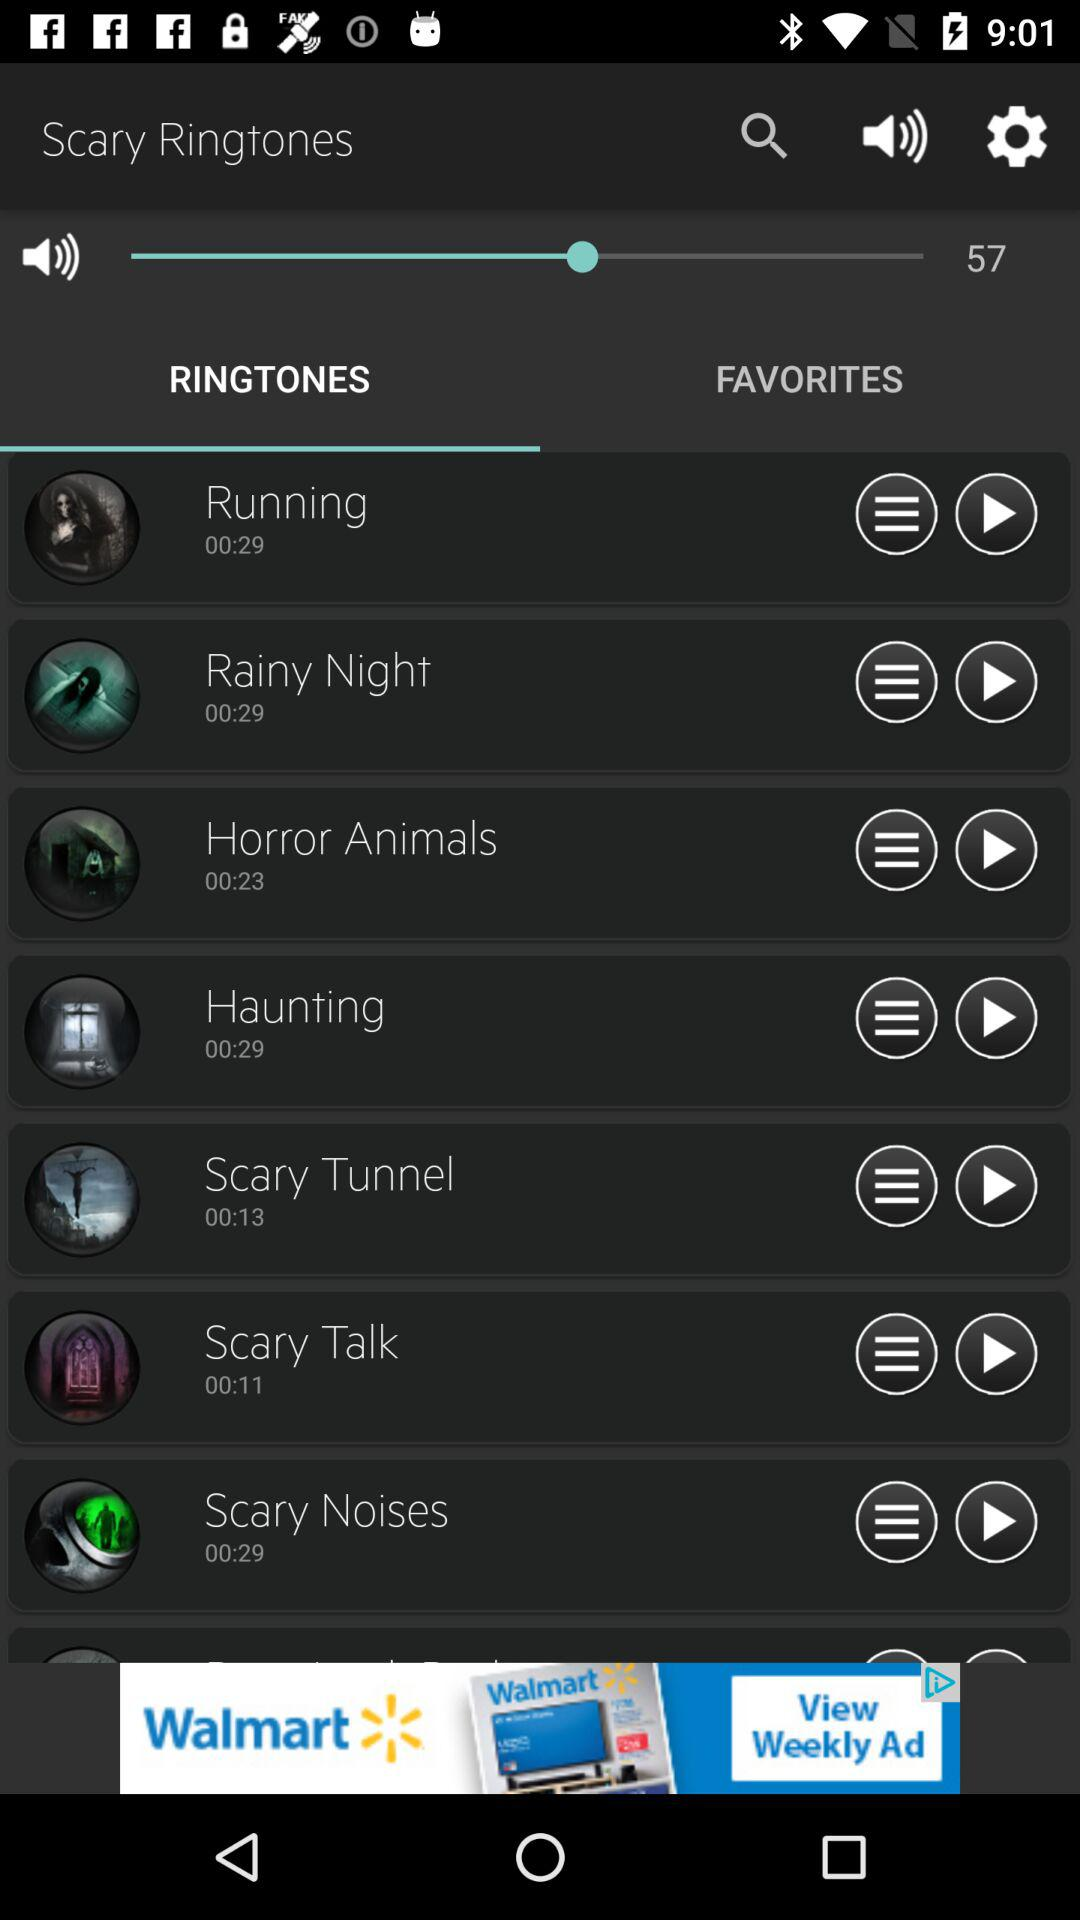How long is the "Rainy Night" ringtone? The "Rainy Night" ringtone is 29 seconds long. 